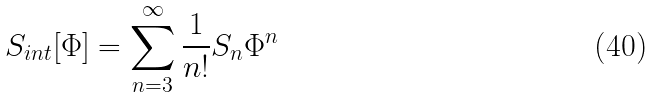<formula> <loc_0><loc_0><loc_500><loc_500>S _ { i n t } [ \Phi ] = \sum _ { n = 3 } ^ { \infty } { \frac { 1 } { n ! } } S _ { n } \Phi ^ { n }</formula> 